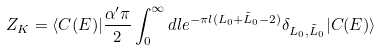<formula> <loc_0><loc_0><loc_500><loc_500>Z _ { K } = \langle C ( E ) | \frac { \alpha ^ { \prime } \pi } { 2 } \int _ { 0 } ^ { \infty } d l e ^ { - \pi l ( L _ { 0 } + \tilde { L } _ { 0 } - 2 ) } \delta _ { L _ { 0 } , \tilde { L } _ { 0 } } | C ( E ) \rangle</formula> 